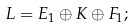Convert formula to latex. <formula><loc_0><loc_0><loc_500><loc_500>L = E _ { 1 } \oplus K \oplus F _ { 1 } ;</formula> 